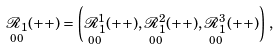<formula> <loc_0><loc_0><loc_500><loc_500>\underset { 0 0 } { \mathcal { R } _ { 1 } } ( + + ) = \left ( \underset { 0 0 } { \mathcal { R } _ { 1 } ^ { 1 } } ( + + ) , \underset { 0 0 } { \mathcal { R } _ { 1 } ^ { 2 } } ( + + ) , \underset { 0 0 } { \mathcal { R } _ { 1 } ^ { 3 } } ( + + ) \right ) \, ,</formula> 